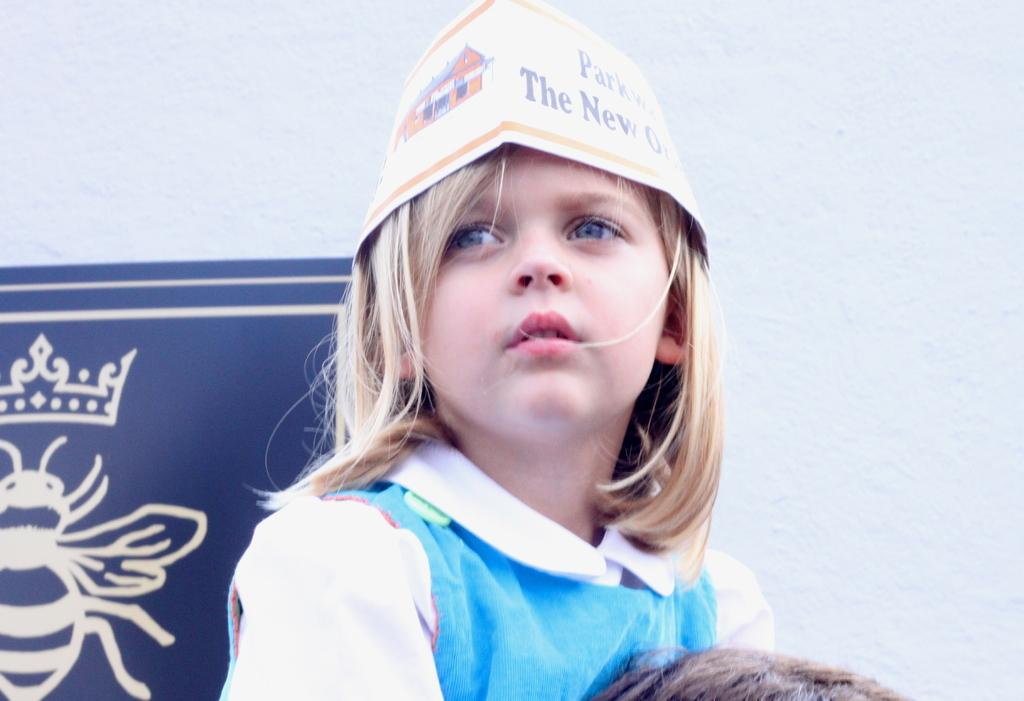<image>
Create a compact narrative representing the image presented. A young girl wearing a hat that says Parkway and New Orleans on it. 